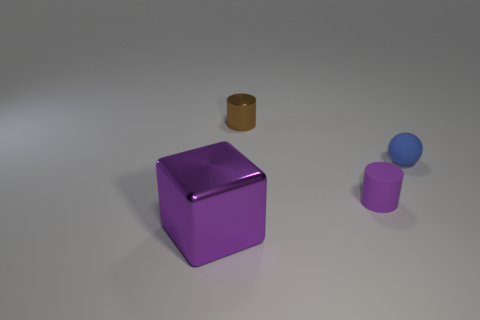What is the shape of the big shiny thing that is the same color as the small matte cylinder?
Your response must be concise. Cube. What number of brown things have the same size as the blue object?
Ensure brevity in your answer.  1. Is the number of brown cylinders to the left of the shiny cylinder less than the number of big shiny blocks?
Your response must be concise. Yes. How many blue rubber spheres are in front of the tiny blue object?
Offer a terse response. 0. What is the size of the purple thing behind the object that is in front of the purple object that is behind the large object?
Offer a terse response. Small. There is a purple rubber thing; is it the same shape as the purple thing to the left of the small brown object?
Offer a very short reply. No. What size is the brown cylinder that is the same material as the purple cube?
Offer a very short reply. Small. Are there any other things of the same color as the matte sphere?
Ensure brevity in your answer.  No. What is the material of the purple object right of the purple thing that is on the left side of the tiny purple rubber cylinder to the left of the small blue matte thing?
Your answer should be compact. Rubber. How many shiny things are spheres or tiny gray balls?
Your response must be concise. 0. 